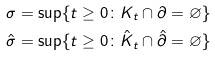Convert formula to latex. <formula><loc_0><loc_0><loc_500><loc_500>\sigma & = \sup \{ t \geq 0 \colon K _ { t } \cap \partial = \varnothing \} \\ \hat { \sigma } & = \sup \{ t \geq 0 \colon \hat { K } _ { t } \cap \hat { \partial } = \varnothing \}</formula> 